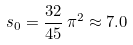<formula> <loc_0><loc_0><loc_500><loc_500>s _ { 0 } = \frac { 3 2 } { 4 5 } \, \pi ^ { 2 } \approx 7 . 0 \,</formula> 